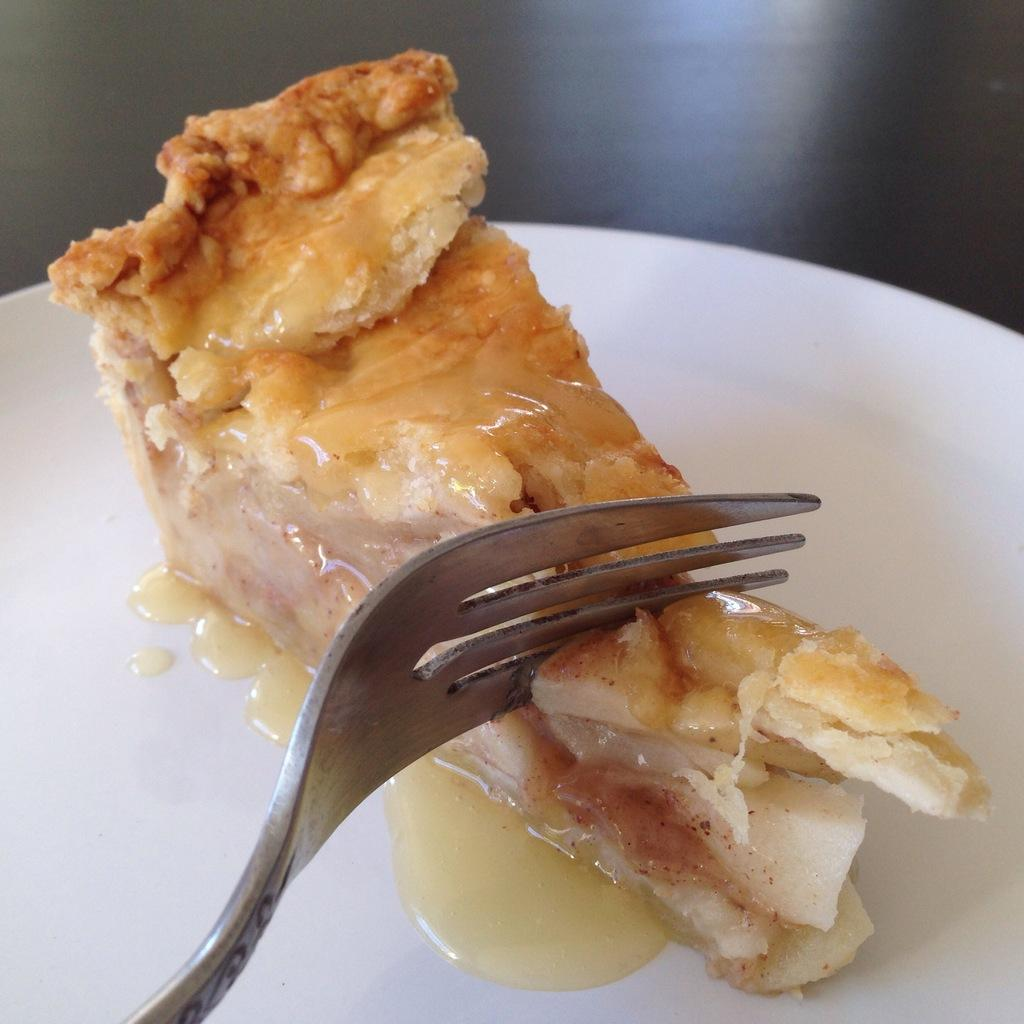What is on the plate that is visible in the image? The plate contains food items. What utensil is placed on the plate? There is a fork on the plate. Where is the plate located in the image? The plate is placed on a table. What type of duck is sitting on the can in the image? There is no duck or can present in the image. 